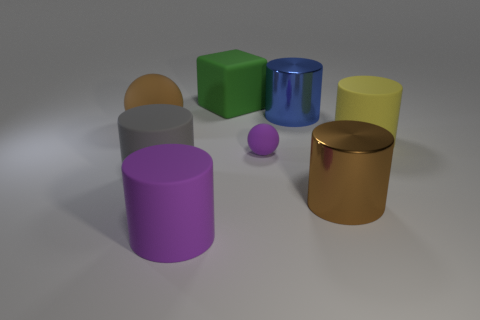Subtract all blue cylinders. How many cylinders are left? 4 Subtract all brown cylinders. How many cylinders are left? 4 Subtract all blue cylinders. Subtract all blue balls. How many cylinders are left? 4 Subtract all cylinders. How many objects are left? 3 Add 2 red matte things. How many objects exist? 10 Subtract 0 blue balls. How many objects are left? 8 Subtract all small green cylinders. Subtract all purple matte balls. How many objects are left? 7 Add 1 large cylinders. How many large cylinders are left? 6 Add 1 purple spheres. How many purple spheres exist? 2 